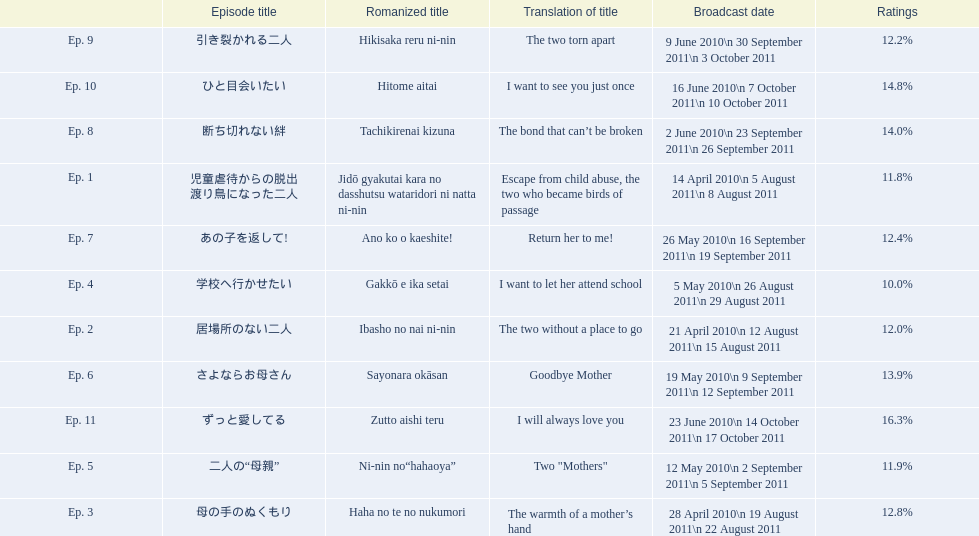Which episode was titled the two without a place to go? Ep. 2. What was the title of ep. 3? The warmth of a mother’s hand. Which episode had a rating of 10.0%? Ep. 4. 